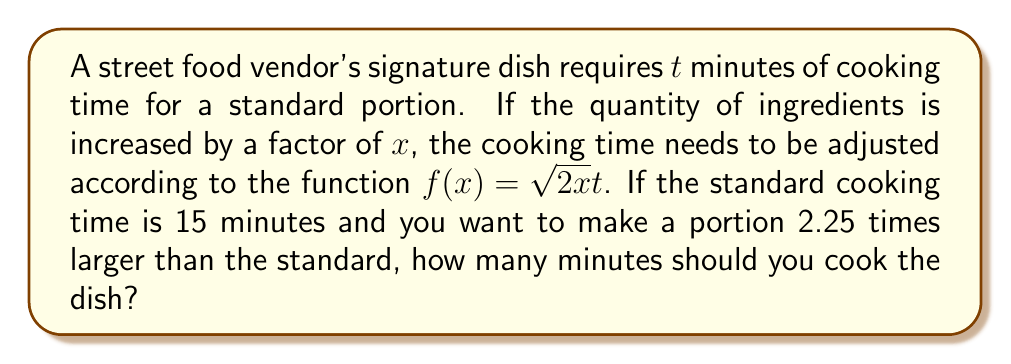Can you solve this math problem? Let's approach this step-by-step:

1) We're given that the standard cooking time $t = 15$ minutes.

2) The function for adjusted cooking time is $f(x) = \sqrt{2x}t$, where $x$ is the factor by which the quantity of ingredients is increased.

3) In this case, we're making a portion 2.25 times larger than the standard, so $x = 2.25$.

4) Let's substitute these values into the function:

   $f(2.25) = \sqrt{2(2.25)}(15)$

5) Let's simplify inside the square root:
   
   $f(2.25) = \sqrt{4.5}(15)$

6) Calculate the square root:
   
   $f(2.25) = (\sqrt{4.5})(15) \approx (2.12132)(15)$

7) Multiply:
   
   $f(2.25) \approx 31.81980$

8) Rounding to the nearest minute (as cooking times are typically given in whole minutes):

   $f(2.25) \approx 32$ minutes
Answer: 32 minutes 